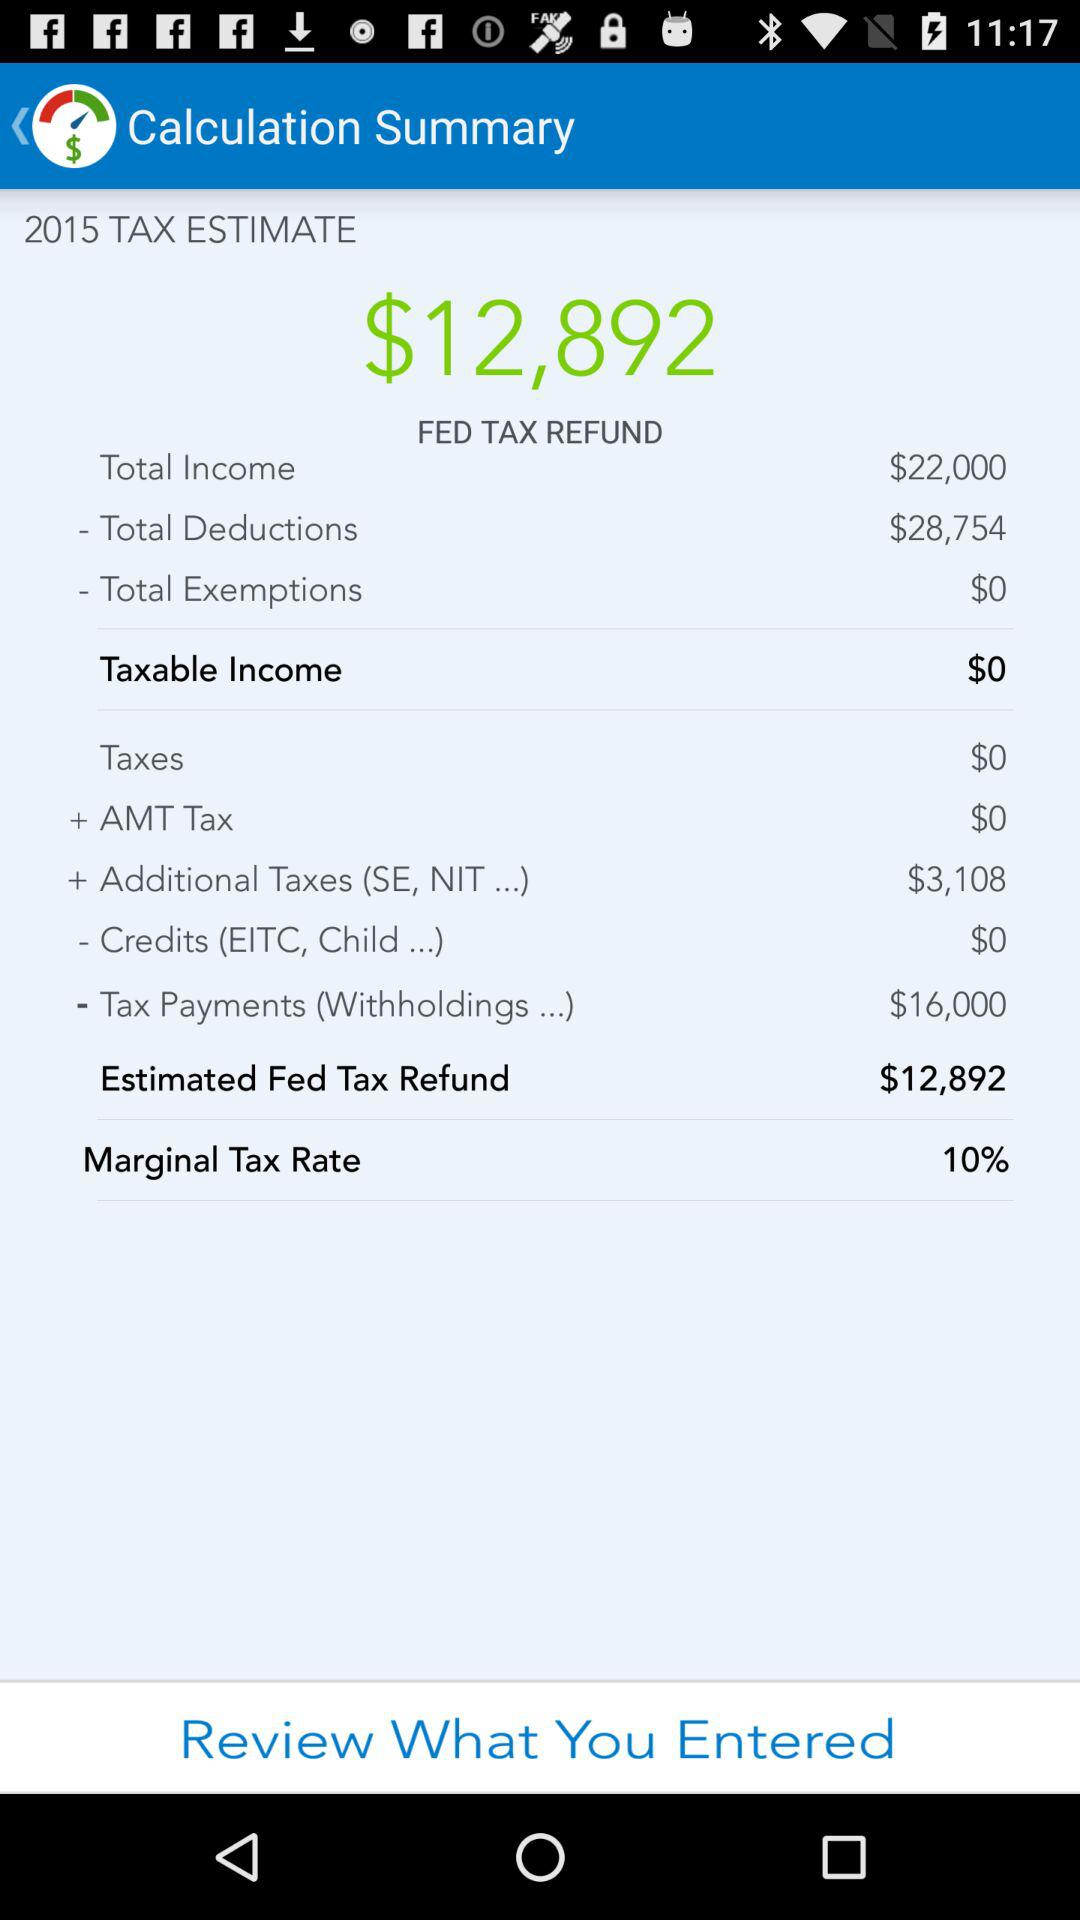What is the "Tax Payments (Withholdings...)" amount? The amount is $16,000. 